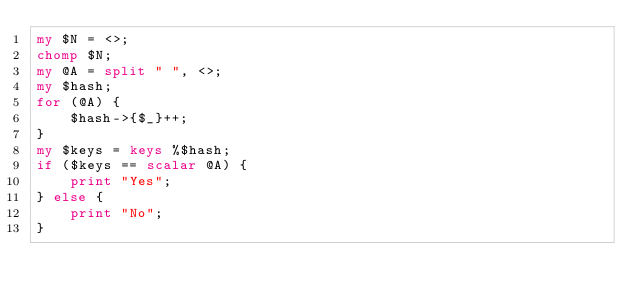Convert code to text. <code><loc_0><loc_0><loc_500><loc_500><_Perl_>my $N = <>;
chomp $N;
my @A = split " ", <>;
my $hash;
for (@A) {
    $hash->{$_}++;
}
my $keys = keys %$hash;
if ($keys == scalar @A) {
    print "Yes";
} else {
    print "No";
}
</code> 